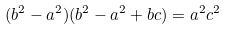Convert formula to latex. <formula><loc_0><loc_0><loc_500><loc_500>\ ( b ^ { 2 } - a ^ { 2 } ) ( b ^ { 2 } - a ^ { 2 } + b c ) = a ^ { 2 } c ^ { 2 }</formula> 